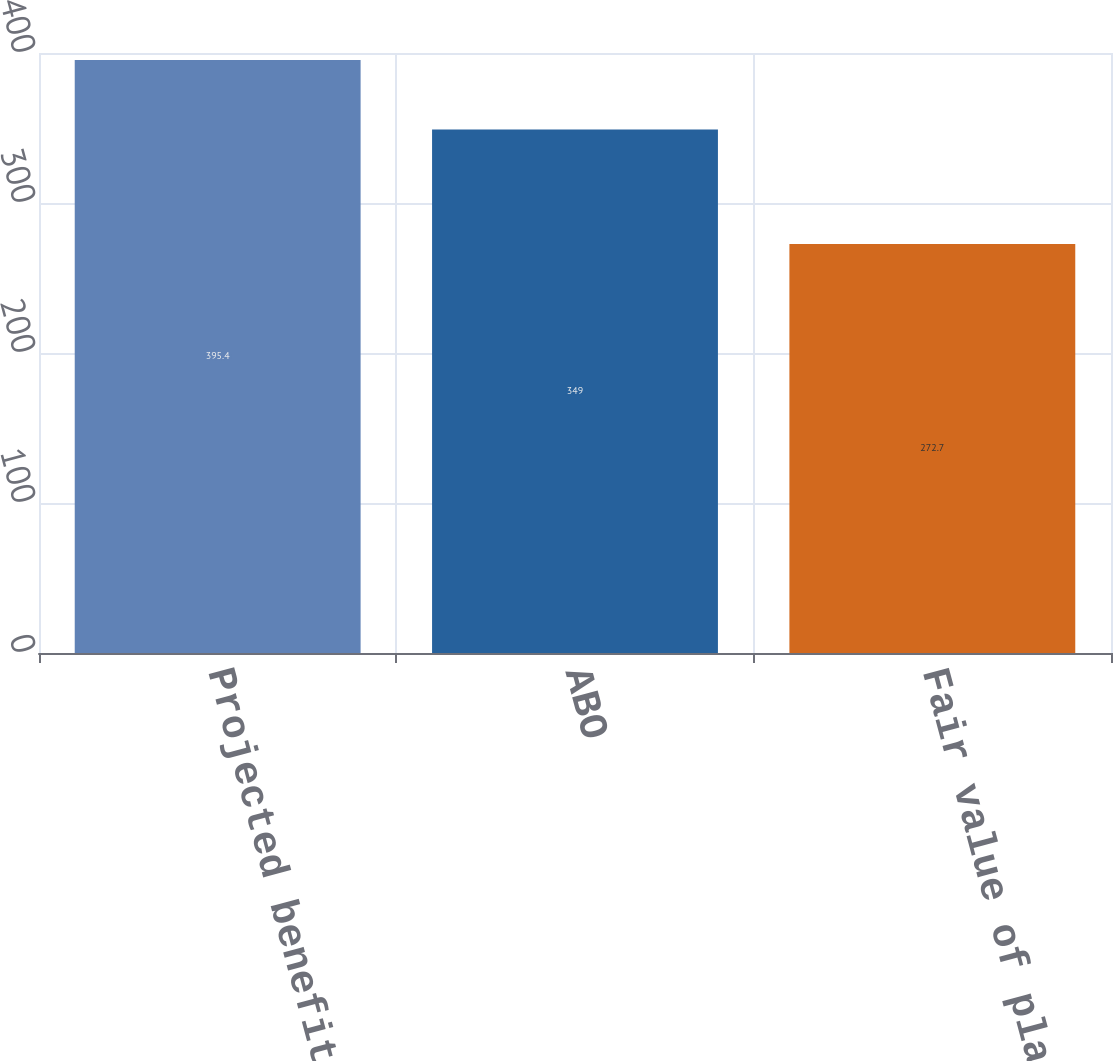<chart> <loc_0><loc_0><loc_500><loc_500><bar_chart><fcel>Projected benefit obligation<fcel>ABO<fcel>Fair value of plan assets<nl><fcel>395.4<fcel>349<fcel>272.7<nl></chart> 